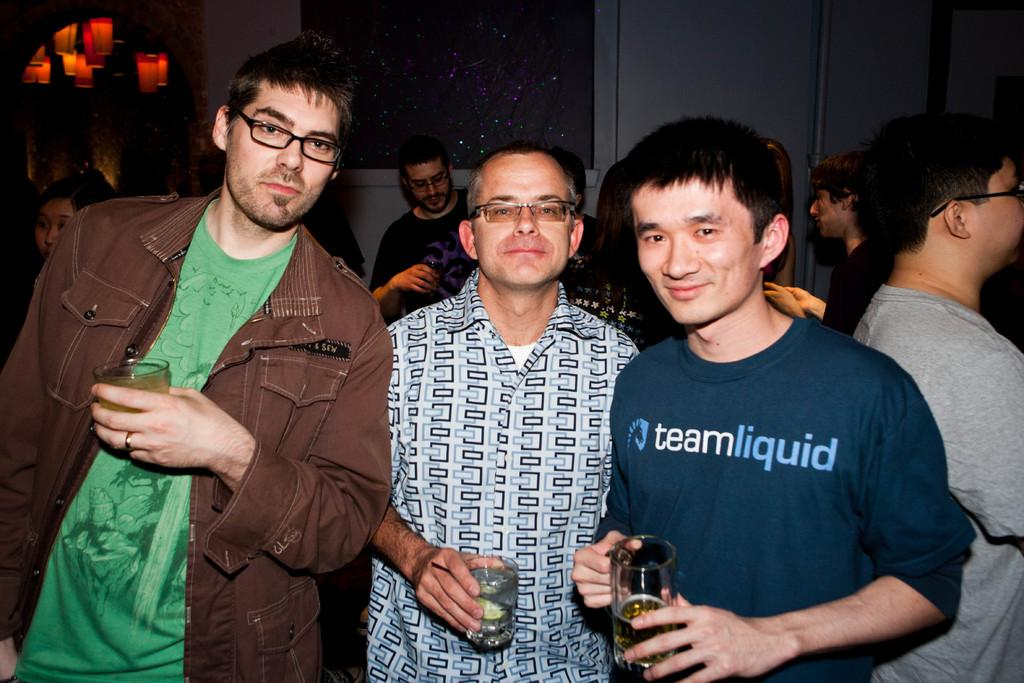What is the main subject of the image? The main subject of the image is a group of people. Can you describe the men standing in front of the group? There are three men standing in front of the group, and they are holding classes in their hands. What is the facial expression of the three men? The three men are smiling. What additional detail can be seen in the image? There are colorful lights visible at the top left of the image. How does the visitor interact with the pail in the image? There is no visitor or pail present in the image. 